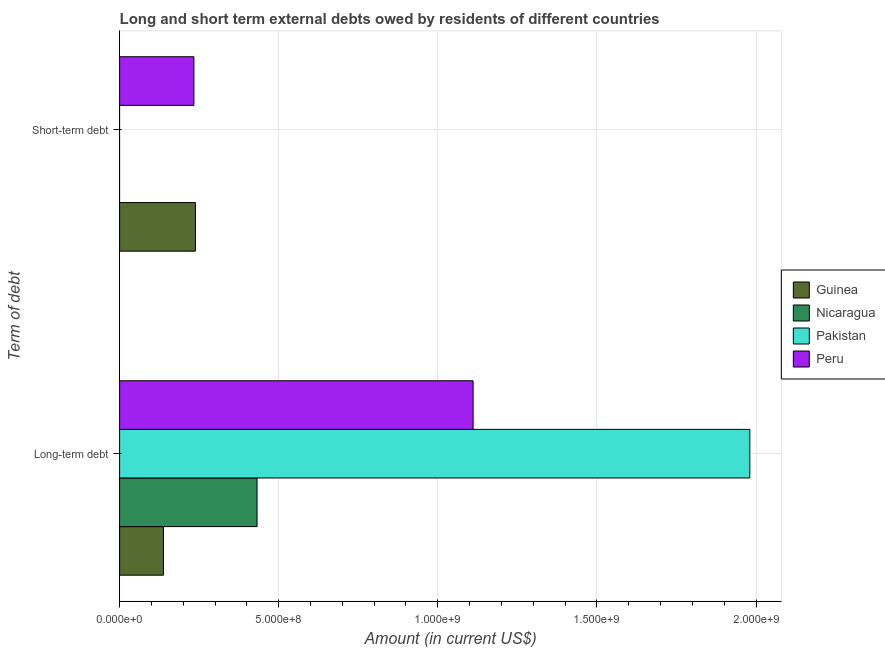Are the number of bars per tick equal to the number of legend labels?
Your answer should be compact. No. Are the number of bars on each tick of the Y-axis equal?
Offer a very short reply. No. What is the label of the 1st group of bars from the top?
Keep it short and to the point. Short-term debt. What is the short-term debts owed by residents in Peru?
Offer a terse response. 2.33e+08. Across all countries, what is the maximum long-term debts owed by residents?
Your response must be concise. 1.98e+09. Across all countries, what is the minimum long-term debts owed by residents?
Give a very brief answer. 1.38e+08. In which country was the short-term debts owed by residents maximum?
Give a very brief answer. Guinea. What is the total long-term debts owed by residents in the graph?
Offer a terse response. 3.66e+09. What is the difference between the long-term debts owed by residents in Pakistan and that in Peru?
Give a very brief answer. 8.70e+08. What is the difference between the short-term debts owed by residents in Guinea and the long-term debts owed by residents in Nicaragua?
Offer a very short reply. -1.94e+08. What is the average short-term debts owed by residents per country?
Offer a terse response. 1.18e+08. What is the difference between the long-term debts owed by residents and short-term debts owed by residents in Guinea?
Your answer should be compact. -1.01e+08. What is the ratio of the long-term debts owed by residents in Nicaragua to that in Pakistan?
Your answer should be very brief. 0.22. Is the long-term debts owed by residents in Peru less than that in Pakistan?
Offer a very short reply. Yes. In how many countries, is the short-term debts owed by residents greater than the average short-term debts owed by residents taken over all countries?
Your answer should be very brief. 2. Are all the bars in the graph horizontal?
Give a very brief answer. Yes. How many countries are there in the graph?
Keep it short and to the point. 4. Does the graph contain any zero values?
Ensure brevity in your answer.  Yes. Where does the legend appear in the graph?
Give a very brief answer. Center right. How many legend labels are there?
Offer a terse response. 4. What is the title of the graph?
Your answer should be very brief. Long and short term external debts owed by residents of different countries. What is the label or title of the Y-axis?
Make the answer very short. Term of debt. What is the Amount (in current US$) of Guinea in Long-term debt?
Ensure brevity in your answer.  1.38e+08. What is the Amount (in current US$) of Nicaragua in Long-term debt?
Your answer should be compact. 4.32e+08. What is the Amount (in current US$) of Pakistan in Long-term debt?
Keep it short and to the point. 1.98e+09. What is the Amount (in current US$) in Peru in Long-term debt?
Offer a terse response. 1.11e+09. What is the Amount (in current US$) in Guinea in Short-term debt?
Give a very brief answer. 2.38e+08. What is the Amount (in current US$) in Pakistan in Short-term debt?
Offer a terse response. 0. What is the Amount (in current US$) in Peru in Short-term debt?
Make the answer very short. 2.33e+08. Across all Term of debt, what is the maximum Amount (in current US$) in Guinea?
Ensure brevity in your answer.  2.38e+08. Across all Term of debt, what is the maximum Amount (in current US$) of Nicaragua?
Make the answer very short. 4.32e+08. Across all Term of debt, what is the maximum Amount (in current US$) of Pakistan?
Keep it short and to the point. 1.98e+09. Across all Term of debt, what is the maximum Amount (in current US$) of Peru?
Provide a short and direct response. 1.11e+09. Across all Term of debt, what is the minimum Amount (in current US$) in Guinea?
Offer a very short reply. 1.38e+08. Across all Term of debt, what is the minimum Amount (in current US$) of Nicaragua?
Offer a terse response. 0. Across all Term of debt, what is the minimum Amount (in current US$) in Pakistan?
Give a very brief answer. 0. Across all Term of debt, what is the minimum Amount (in current US$) in Peru?
Give a very brief answer. 2.33e+08. What is the total Amount (in current US$) in Guinea in the graph?
Your answer should be compact. 3.76e+08. What is the total Amount (in current US$) in Nicaragua in the graph?
Offer a very short reply. 4.32e+08. What is the total Amount (in current US$) of Pakistan in the graph?
Offer a very short reply. 1.98e+09. What is the total Amount (in current US$) of Peru in the graph?
Keep it short and to the point. 1.34e+09. What is the difference between the Amount (in current US$) in Guinea in Long-term debt and that in Short-term debt?
Ensure brevity in your answer.  -1.01e+08. What is the difference between the Amount (in current US$) of Peru in Long-term debt and that in Short-term debt?
Ensure brevity in your answer.  8.77e+08. What is the difference between the Amount (in current US$) in Guinea in Long-term debt and the Amount (in current US$) in Peru in Short-term debt?
Give a very brief answer. -9.58e+07. What is the difference between the Amount (in current US$) of Nicaragua in Long-term debt and the Amount (in current US$) of Peru in Short-term debt?
Ensure brevity in your answer.  1.98e+08. What is the difference between the Amount (in current US$) in Pakistan in Long-term debt and the Amount (in current US$) in Peru in Short-term debt?
Your answer should be very brief. 1.75e+09. What is the average Amount (in current US$) of Guinea per Term of debt?
Make the answer very short. 1.88e+08. What is the average Amount (in current US$) in Nicaragua per Term of debt?
Your answer should be very brief. 2.16e+08. What is the average Amount (in current US$) in Pakistan per Term of debt?
Keep it short and to the point. 9.90e+08. What is the average Amount (in current US$) in Peru per Term of debt?
Your answer should be very brief. 6.72e+08. What is the difference between the Amount (in current US$) of Guinea and Amount (in current US$) of Nicaragua in Long-term debt?
Keep it short and to the point. -2.94e+08. What is the difference between the Amount (in current US$) of Guinea and Amount (in current US$) of Pakistan in Long-term debt?
Give a very brief answer. -1.84e+09. What is the difference between the Amount (in current US$) in Guinea and Amount (in current US$) in Peru in Long-term debt?
Offer a terse response. -9.73e+08. What is the difference between the Amount (in current US$) of Nicaragua and Amount (in current US$) of Pakistan in Long-term debt?
Your response must be concise. -1.55e+09. What is the difference between the Amount (in current US$) of Nicaragua and Amount (in current US$) of Peru in Long-term debt?
Your answer should be compact. -6.79e+08. What is the difference between the Amount (in current US$) in Pakistan and Amount (in current US$) in Peru in Long-term debt?
Your response must be concise. 8.70e+08. What is the difference between the Amount (in current US$) of Guinea and Amount (in current US$) of Peru in Short-term debt?
Offer a terse response. 4.78e+06. What is the ratio of the Amount (in current US$) in Guinea in Long-term debt to that in Short-term debt?
Offer a terse response. 0.58. What is the ratio of the Amount (in current US$) of Peru in Long-term debt to that in Short-term debt?
Ensure brevity in your answer.  4.76. What is the difference between the highest and the second highest Amount (in current US$) of Guinea?
Offer a terse response. 1.01e+08. What is the difference between the highest and the second highest Amount (in current US$) in Peru?
Your answer should be compact. 8.77e+08. What is the difference between the highest and the lowest Amount (in current US$) in Guinea?
Provide a short and direct response. 1.01e+08. What is the difference between the highest and the lowest Amount (in current US$) in Nicaragua?
Your answer should be very brief. 4.32e+08. What is the difference between the highest and the lowest Amount (in current US$) of Pakistan?
Offer a terse response. 1.98e+09. What is the difference between the highest and the lowest Amount (in current US$) of Peru?
Provide a succinct answer. 8.77e+08. 